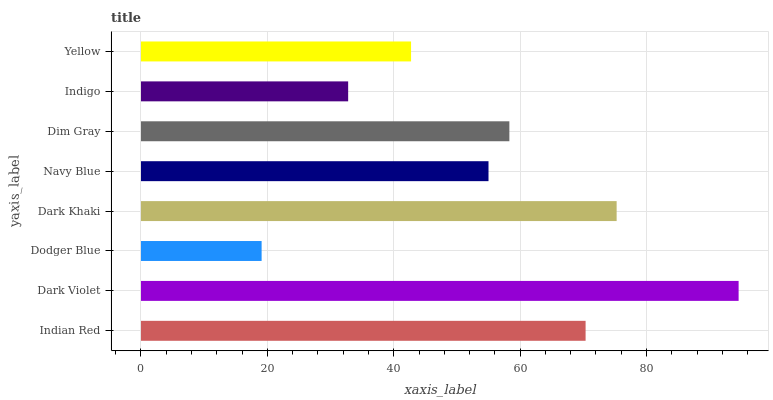Is Dodger Blue the minimum?
Answer yes or no. Yes. Is Dark Violet the maximum?
Answer yes or no. Yes. Is Dark Violet the minimum?
Answer yes or no. No. Is Dodger Blue the maximum?
Answer yes or no. No. Is Dark Violet greater than Dodger Blue?
Answer yes or no. Yes. Is Dodger Blue less than Dark Violet?
Answer yes or no. Yes. Is Dodger Blue greater than Dark Violet?
Answer yes or no. No. Is Dark Violet less than Dodger Blue?
Answer yes or no. No. Is Dim Gray the high median?
Answer yes or no. Yes. Is Navy Blue the low median?
Answer yes or no. Yes. Is Navy Blue the high median?
Answer yes or no. No. Is Indian Red the low median?
Answer yes or no. No. 